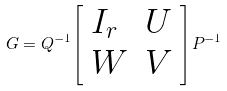<formula> <loc_0><loc_0><loc_500><loc_500>G = Q ^ { - 1 } { \left [ \begin{array} { l l } { I _ { r } } & { U } \\ { W } & { V } \end{array} \right ] } P ^ { - 1 }</formula> 